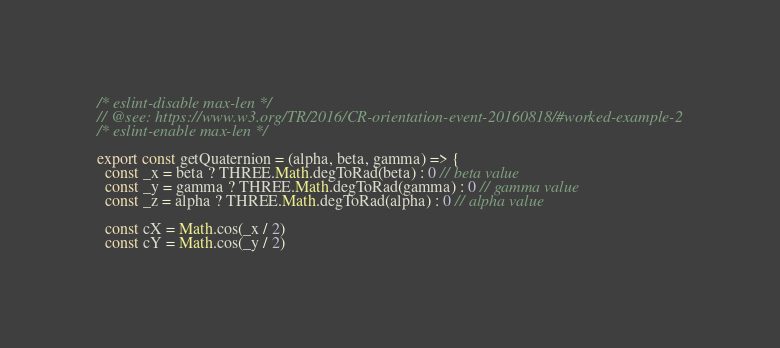Convert code to text. <code><loc_0><loc_0><loc_500><loc_500><_JavaScript_>/* eslint-disable max-len */
// @see: https://www.w3.org/TR/2016/CR-orientation-event-20160818/#worked-example-2
/* eslint-enable max-len */

export const getQuaternion = (alpha, beta, gamma) => {
  const _x = beta ? THREE.Math.degToRad(beta) : 0 // beta value
  const _y = gamma ? THREE.Math.degToRad(gamma) : 0 // gamma value
  const _z = alpha ? THREE.Math.degToRad(alpha) : 0 // alpha value

  const cX = Math.cos(_x / 2)
  const cY = Math.cos(_y / 2)</code> 